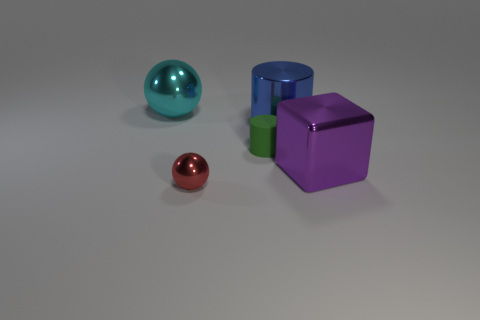Add 1 big cyan metal spheres. How many objects exist? 6 Subtract 1 cylinders. How many cylinders are left? 1 Subtract all green cylinders. How many cylinders are left? 1 Subtract all spheres. How many objects are left? 3 Add 1 purple cubes. How many purple cubes are left? 2 Add 1 green matte cylinders. How many green matte cylinders exist? 2 Subtract 0 red cylinders. How many objects are left? 5 Subtract all gray cubes. Subtract all green cylinders. How many cubes are left? 1 Subtract all big cyan shiny spheres. Subtract all blue cylinders. How many objects are left? 3 